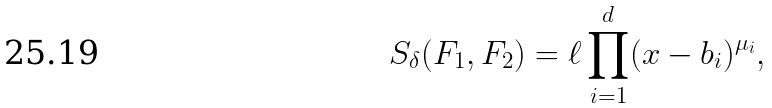<formula> <loc_0><loc_0><loc_500><loc_500>S _ { \delta } ( F _ { 1 } , F _ { 2 } ) = \ell \prod _ { i = 1 } ^ { d } ( x - b _ { i } ) ^ { \mu _ { i } } ,</formula> 